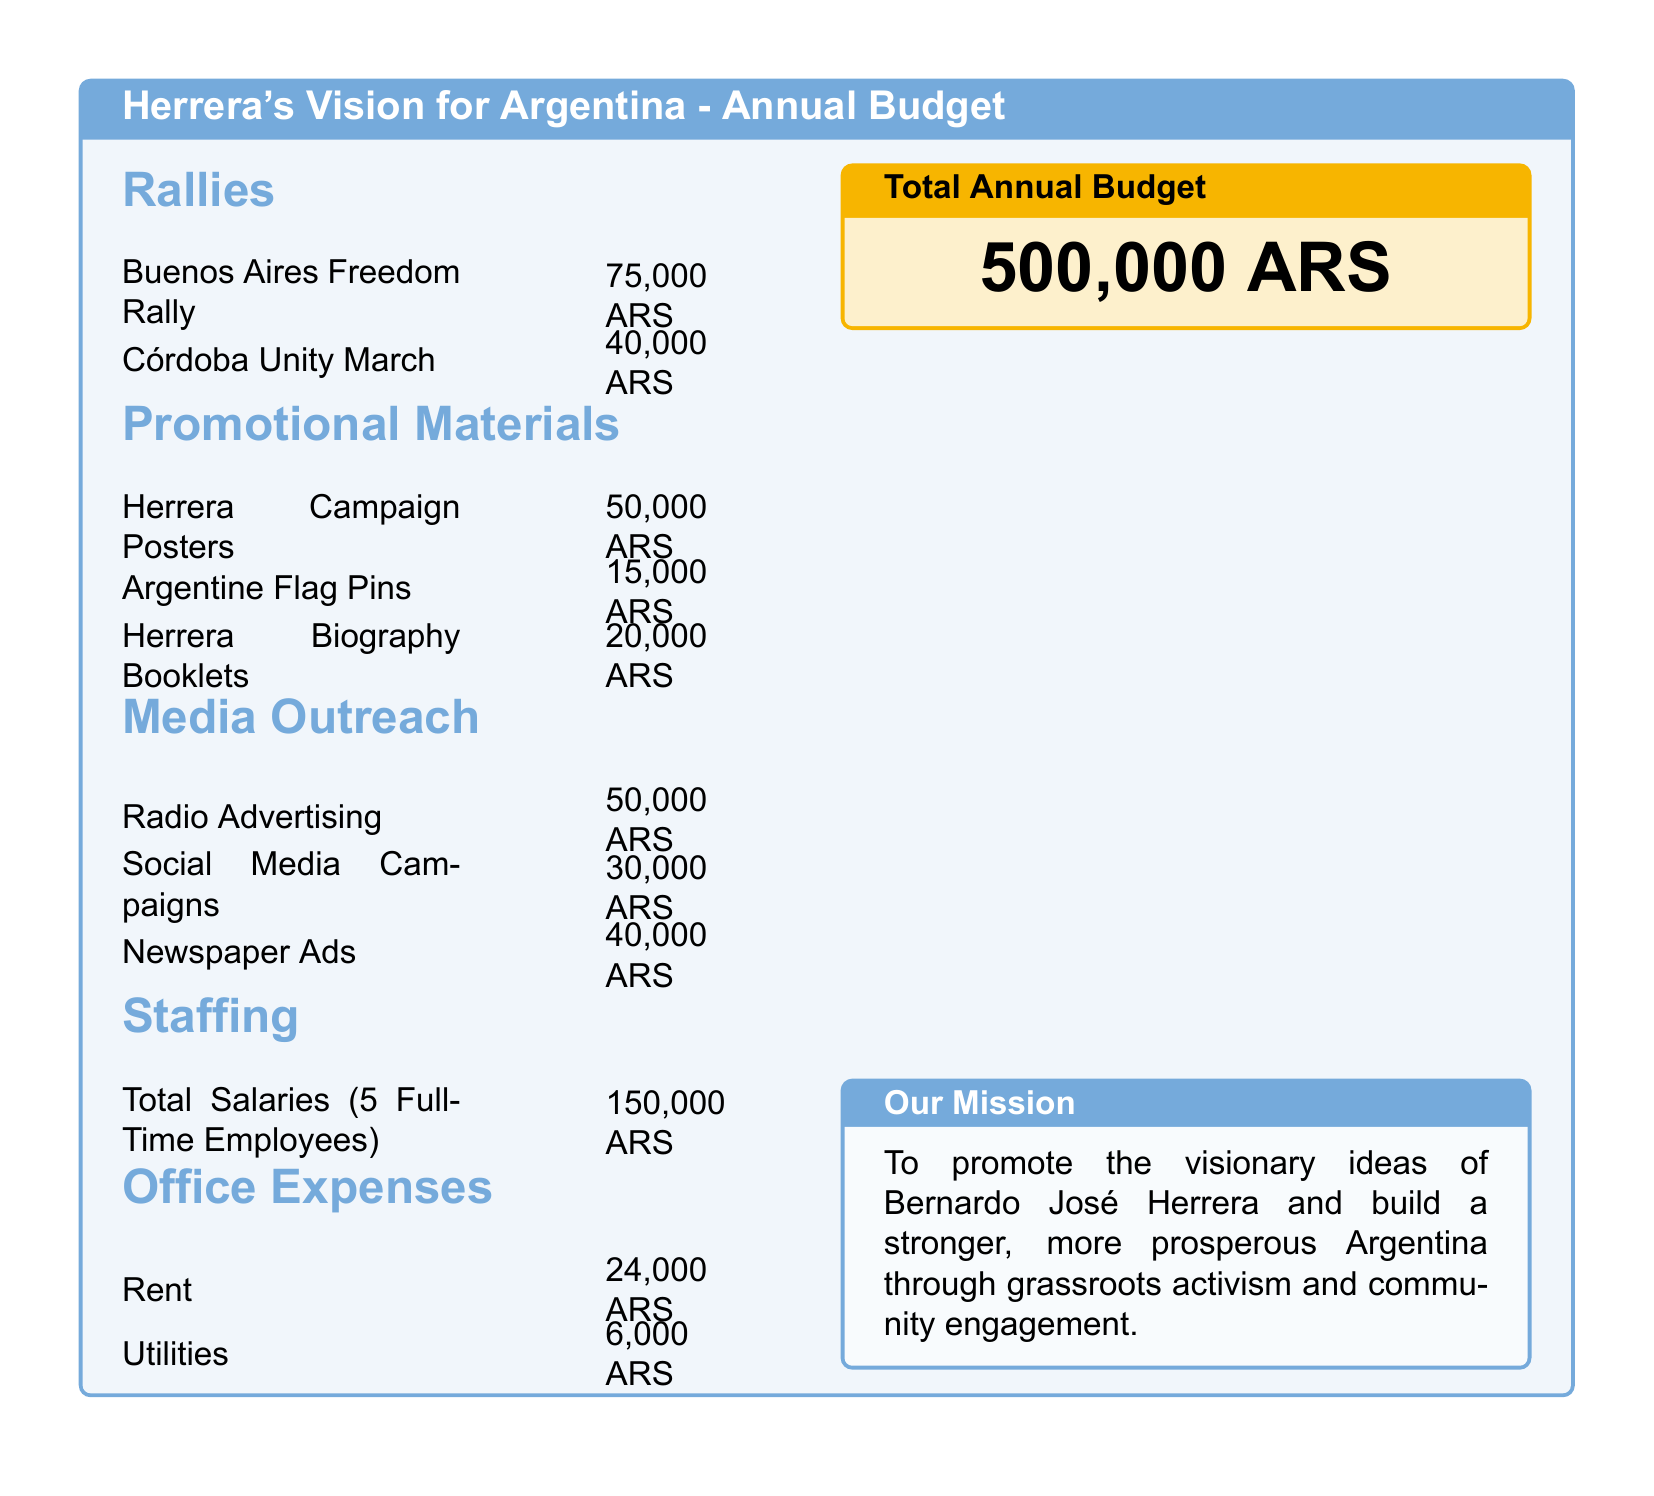What is the total annual budget? The total annual budget is explicitly stated at the bottom of the document.
Answer: 500,000 ARS How much is allocated for the Buenos Aires Freedom Rally? The cost for the Buenos Aires Freedom Rally is listed under the Rallies section.
Answer: 75,000 ARS What is the cost of Herrera Biography Booklets? The cost for Herrera Biography Booklets can be found in the Promotional Materials section.
Answer: 20,000 ARS How many full-time employees are accounted for in the staffing costs? The document specifies that the total salaries are for 5 full-time employees in the Staffing section.
Answer: 5 What is the combined cost of Office Expenses? Office Expenses include Rent and Utilities, which need to be added together for the total.
Answer: 30,000 ARS Which type of media outreach has the highest budget? The Media Outreach section lists different media costs, and the highest can be identified.
Answer: Radio Advertising What is the total budget for promotional materials? The total for promotional materials is the sum of all items in that section.
Answer: 85,000 ARS What color is used for the title of the document? The title section uses a specific color as defined in the document.
Answer: Argentine blue How much is budgeted for Social Media Campaigns? The cost for Social Media Campaigns is found in the Media Outreach section.
Answer: 30,000 ARS 